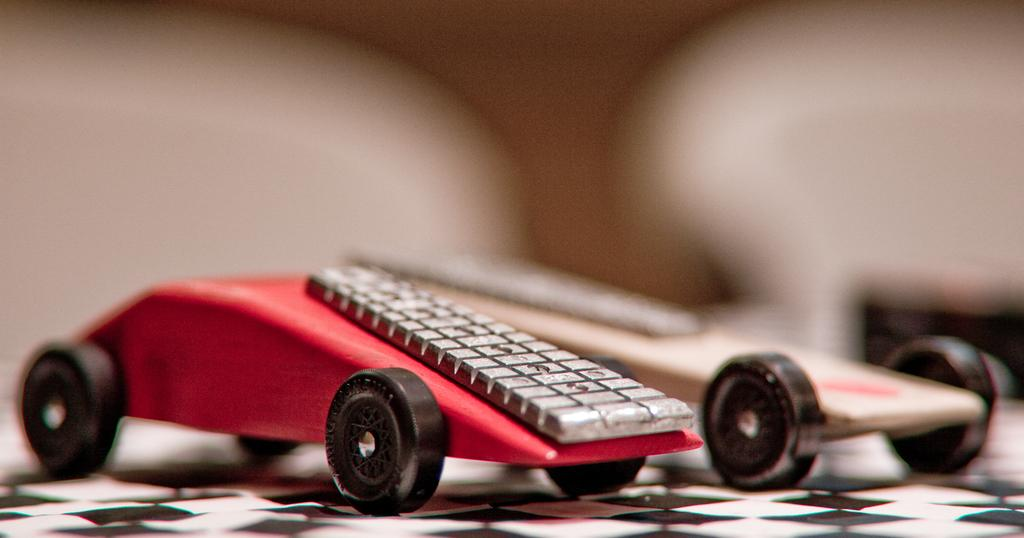How many toys are present in the image? There are two toys in the image. What is a notable feature of the toys? The toys have wheels. Where are the toys located in the image? The toys are placed on a surface. What type of fuel is required for the toys to operate in the image? The toys do not require any fuel to operate, as they are likely inanimate objects and not actual vehicles. 